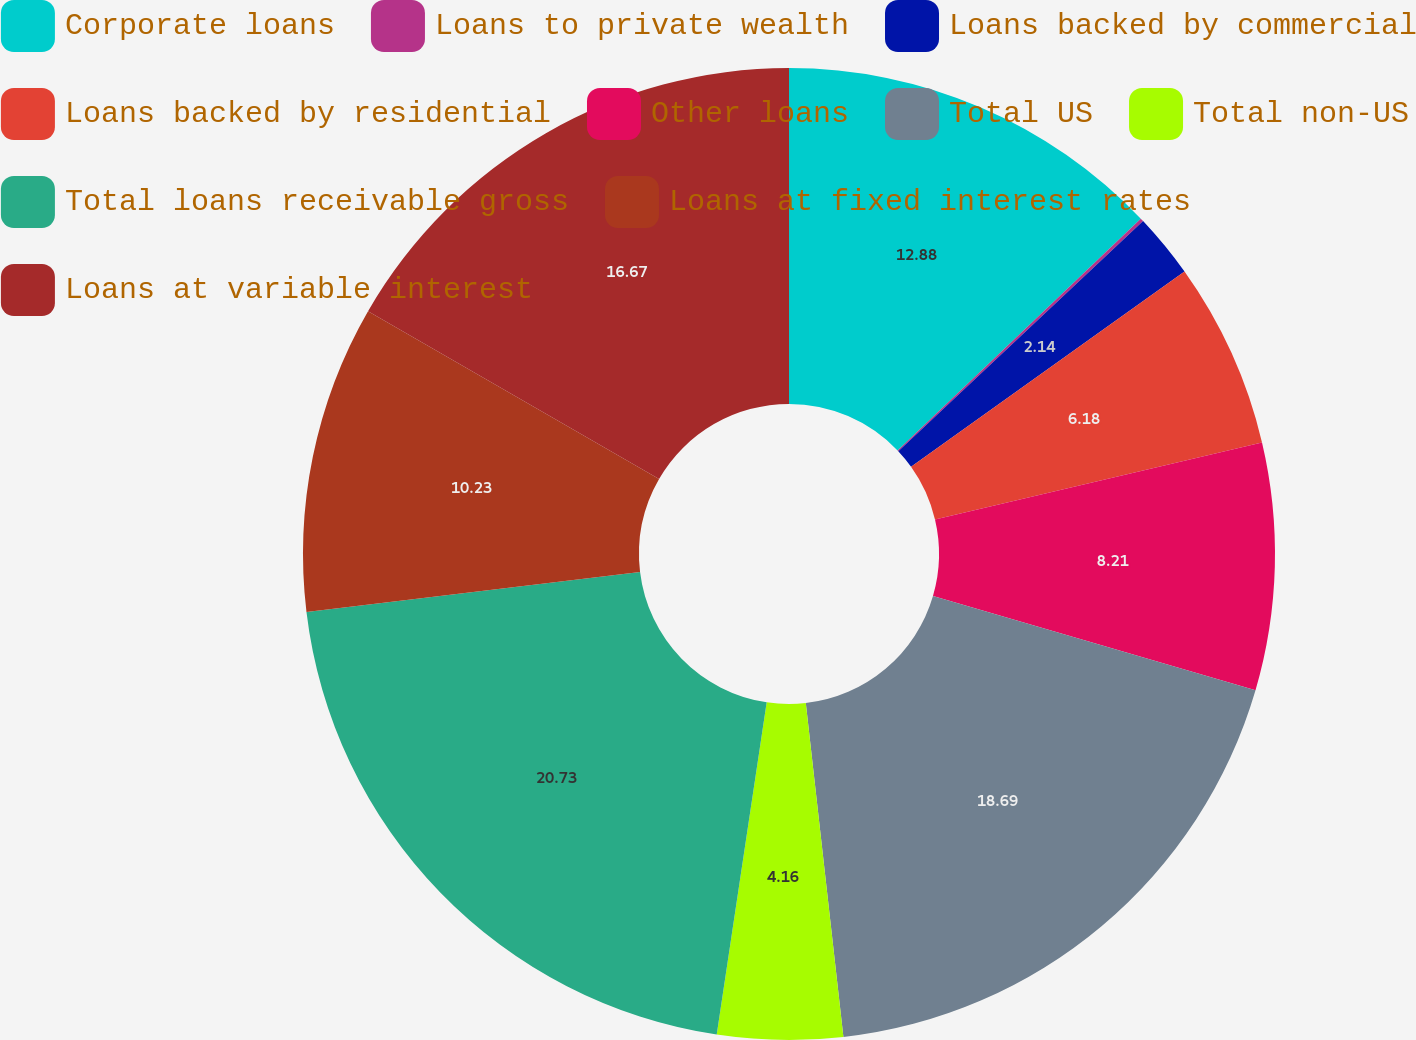Convert chart to OTSL. <chart><loc_0><loc_0><loc_500><loc_500><pie_chart><fcel>Corporate loans<fcel>Loans to private wealth<fcel>Loans backed by commercial<fcel>Loans backed by residential<fcel>Other loans<fcel>Total US<fcel>Total non-US<fcel>Total loans receivable gross<fcel>Loans at fixed interest rates<fcel>Loans at variable interest<nl><fcel>12.88%<fcel>0.11%<fcel>2.14%<fcel>6.18%<fcel>8.21%<fcel>18.69%<fcel>4.16%<fcel>20.72%<fcel>10.23%<fcel>16.67%<nl></chart> 